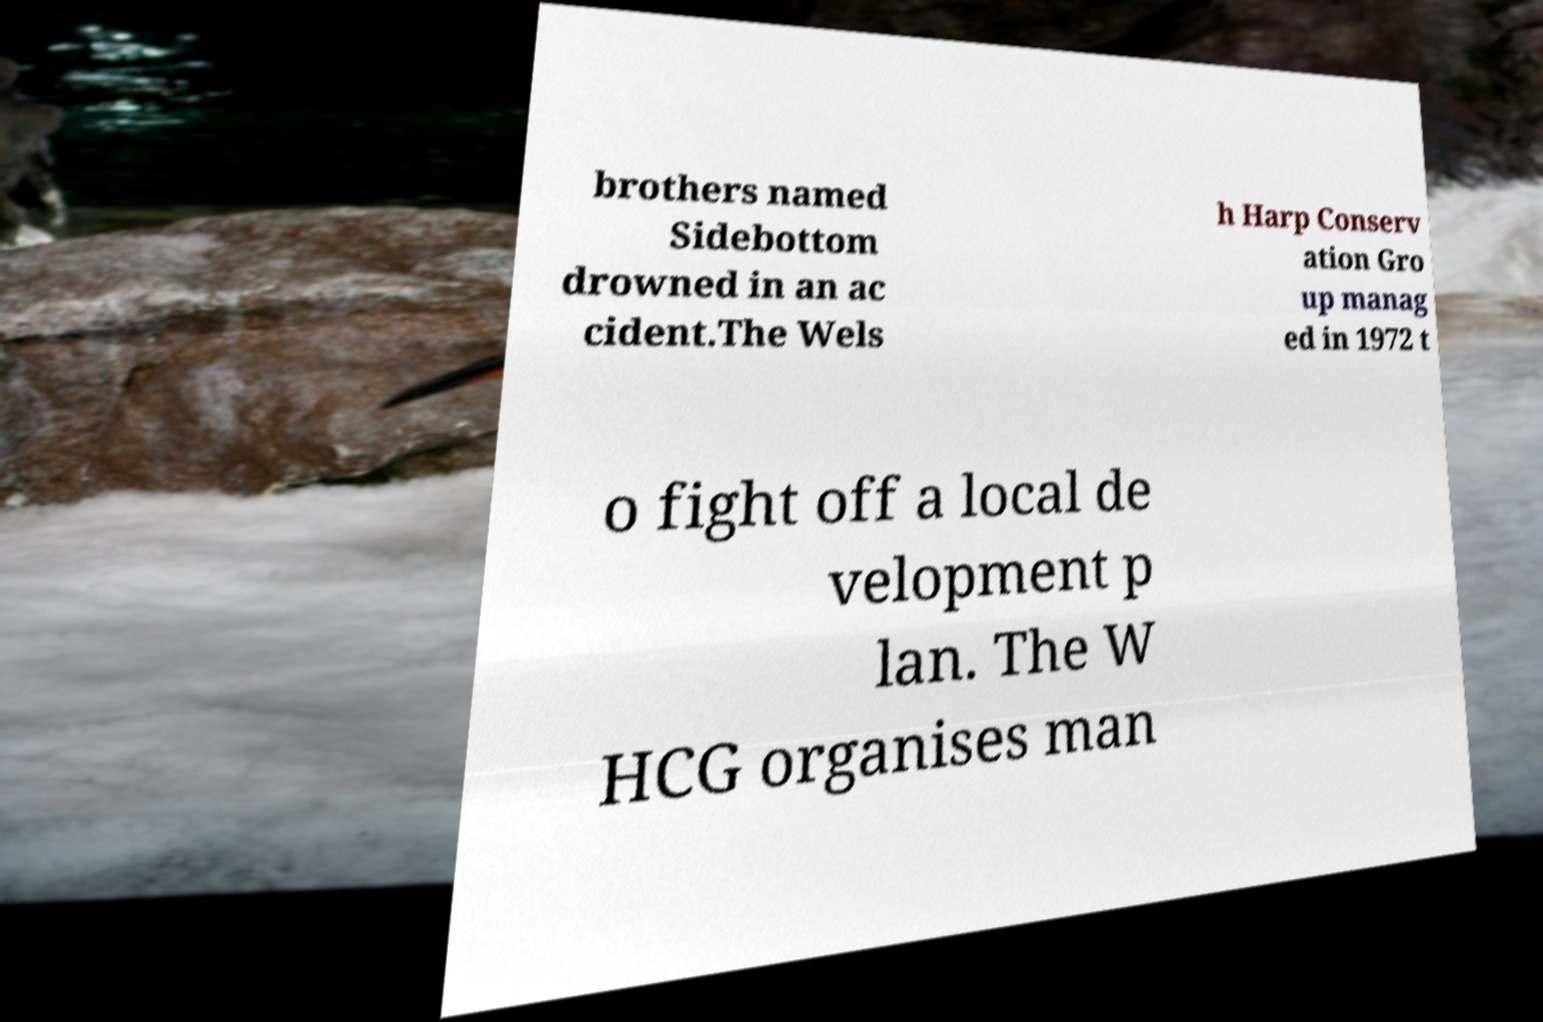For documentation purposes, I need the text within this image transcribed. Could you provide that? brothers named Sidebottom drowned in an ac cident.The Wels h Harp Conserv ation Gro up manag ed in 1972 t o fight off a local de velopment p lan. The W HCG organises man 